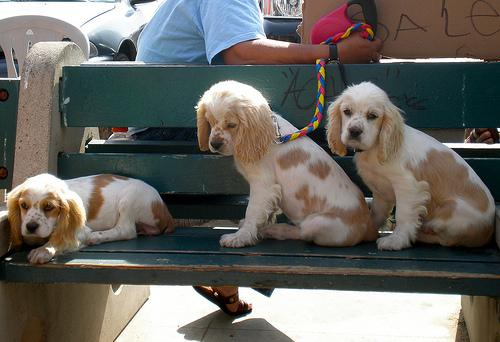Question: how is the item in middle of photo being secured?
Choices:
A. Tape.
B. Rope.
C. Straps.
D. Leash.
Answer with the letter. Answer: D Question: why is the dog on far left probably lying down?
Choices:
A. Tired.
B. Sleeping.
C. Dead.
D. Resting.
Answer with the letter. Answer: D Question: what colors are the three dogs?
Choices:
A. Light brown and white.
B. Grey.
C. Black.
D. Tan.
Answer with the letter. Answer: A Question: where are the three dogs located?
Choices:
A. Field.
B. Yard.
C. Bench.
D. House.
Answer with the letter. Answer: C 